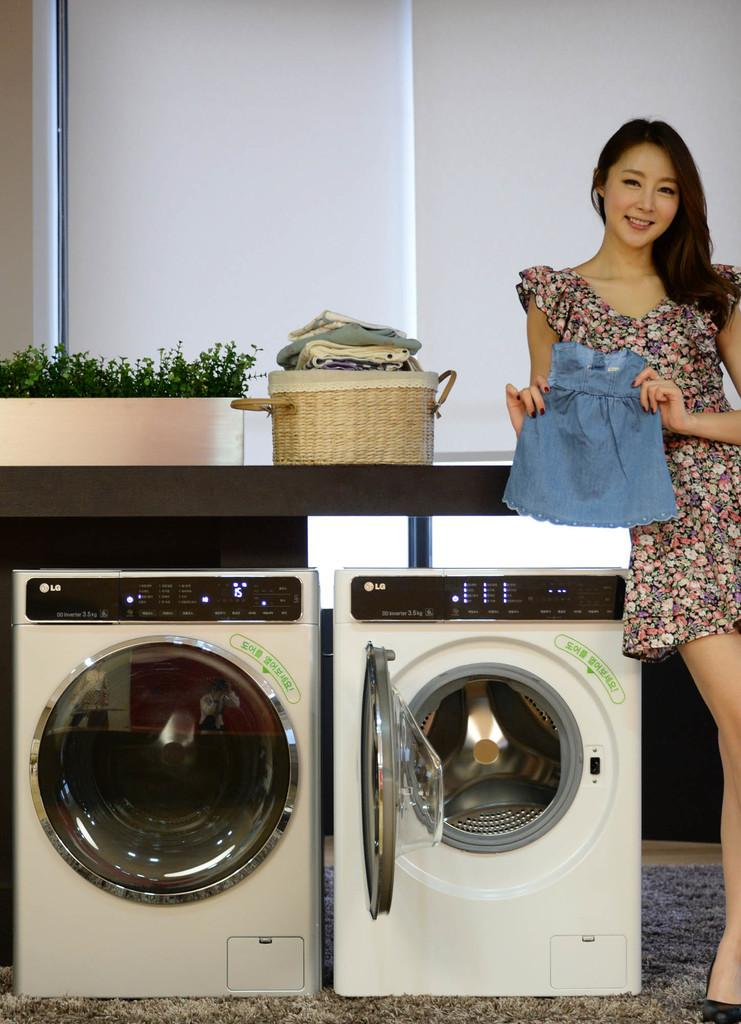<image>
Relay a brief, clear account of the picture shown. A woman leaning up against a set of LG laundry machines. 